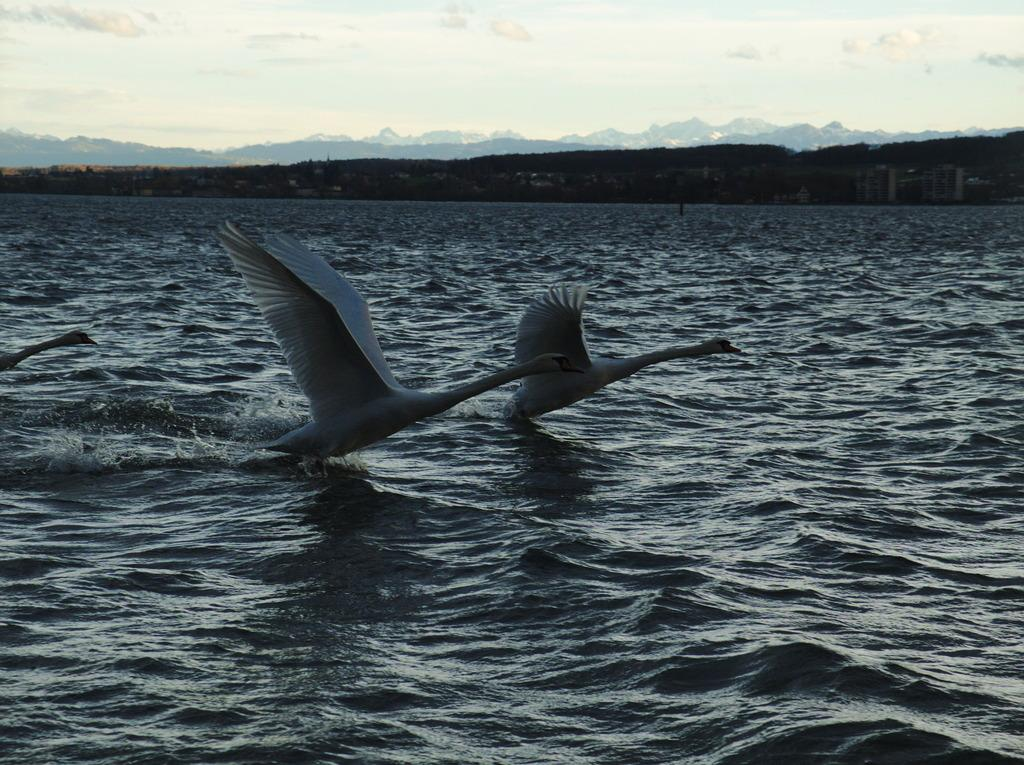What type of animals are in the image? There are cranes in the image. Where are the cranes located? The cranes are in the water. What is the cranes' belief about the vessel in the image? There is no vessel present in the image, and therefore the cranes' beliefs cannot be determined. 